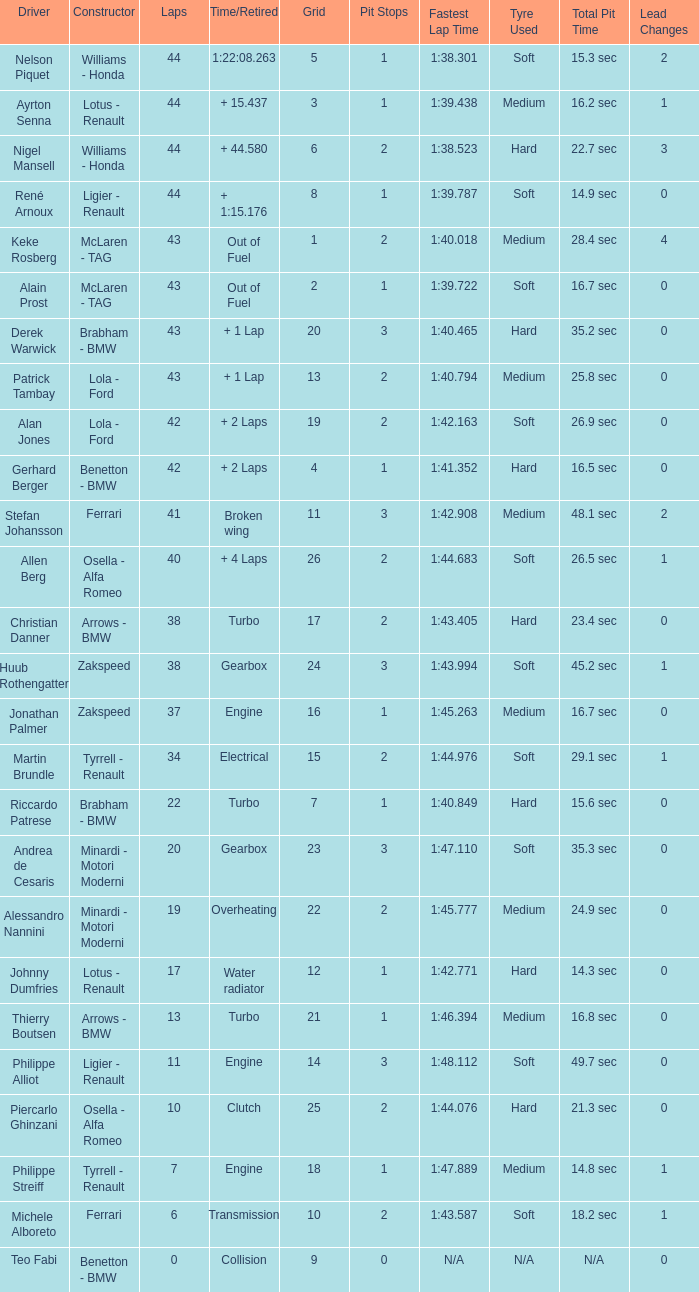Tell me the time/retired for Laps of 42 and Grids of 4 + 2 Laps. 